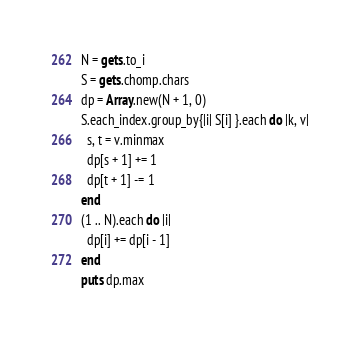<code> <loc_0><loc_0><loc_500><loc_500><_Ruby_>N = gets.to_i
S = gets.chomp.chars
dp = Array.new(N + 1, 0)
S.each_index.group_by{|i| S[i] }.each do |k, v|
  s, t = v.minmax
  dp[s + 1] += 1
  dp[t + 1] -= 1
end
(1 .. N).each do |i|
  dp[i] += dp[i - 1]
end
puts dp.max</code> 